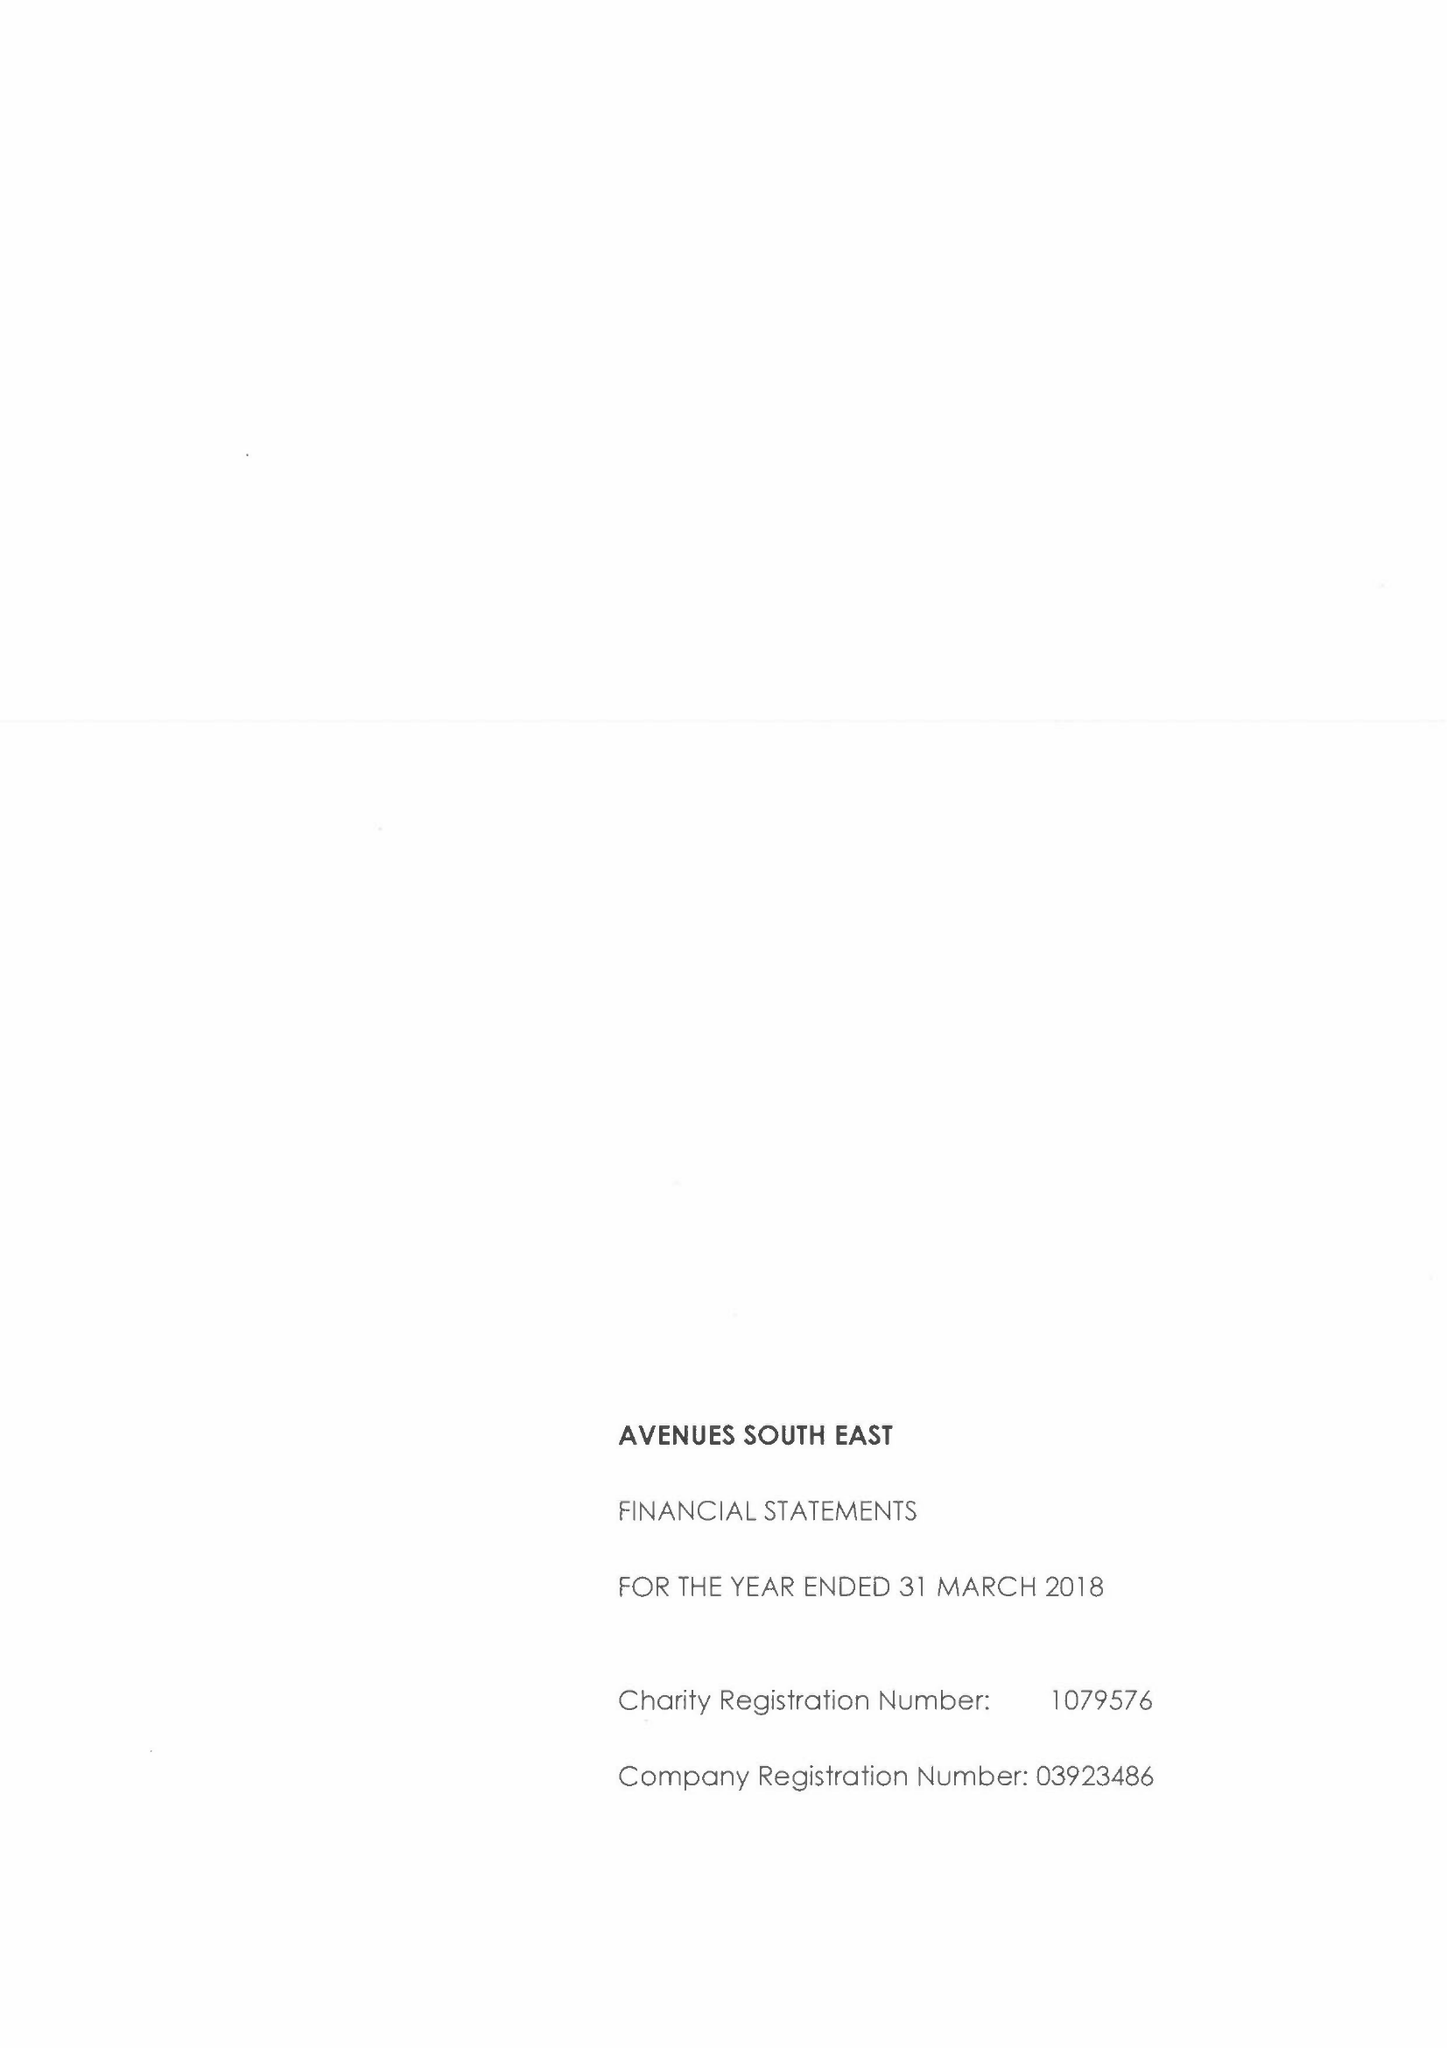What is the value for the charity_name?
Answer the question using a single word or phrase. Avenues South East 